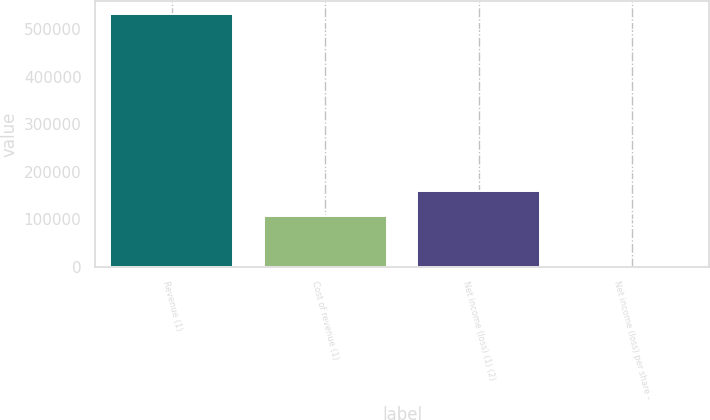Convert chart. <chart><loc_0><loc_0><loc_500><loc_500><bar_chart><fcel>Revenue (1)<fcel>Cost of revenue (1)<fcel>Net income (loss) (1) (2)<fcel>Net income (loss) per share -<nl><fcel>532468<fcel>106494<fcel>159741<fcel>0.35<nl></chart> 